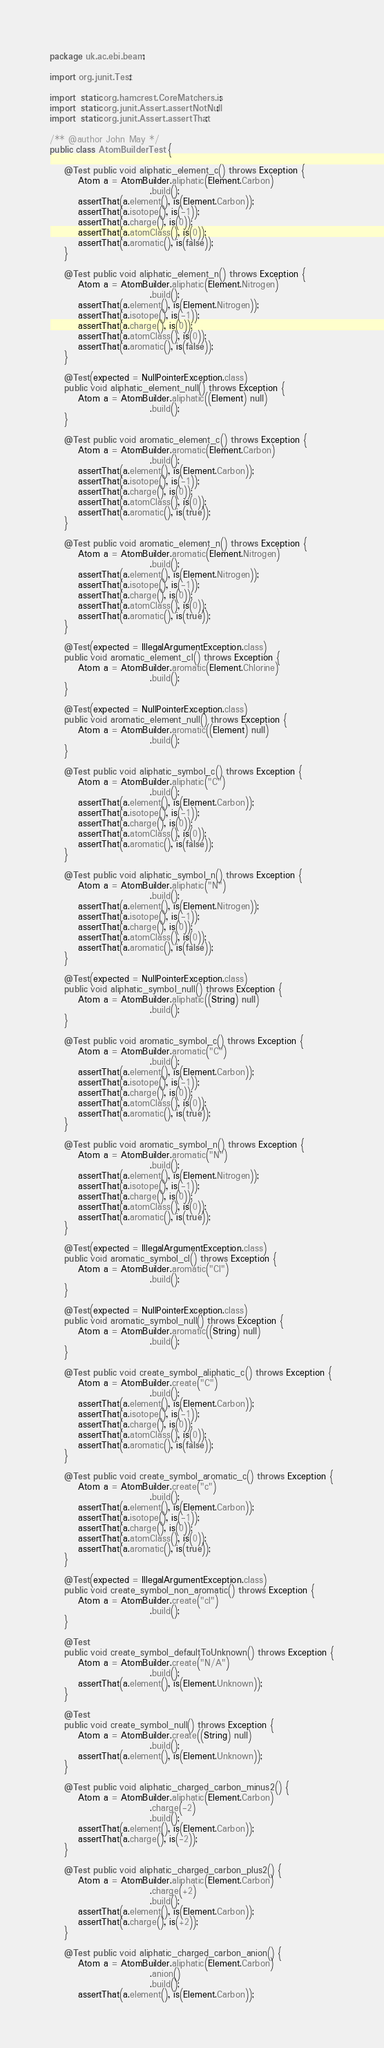Convert code to text. <code><loc_0><loc_0><loc_500><loc_500><_Java_>package uk.ac.ebi.beam;

import org.junit.Test;

import static org.hamcrest.CoreMatchers.is;
import static org.junit.Assert.assertNotNull;
import static org.junit.Assert.assertThat;

/** @author John May */
public class AtomBuilderTest {

    @Test public void aliphatic_element_c() throws Exception {
        Atom a = AtomBuilder.aliphatic(Element.Carbon)
                            .build();
        assertThat(a.element(), is(Element.Carbon));
        assertThat(a.isotope(), is(-1));
        assertThat(a.charge(), is(0));
        assertThat(a.atomClass(), is(0));
        assertThat(a.aromatic(), is(false));
    }

    @Test public void aliphatic_element_n() throws Exception {
        Atom a = AtomBuilder.aliphatic(Element.Nitrogen)
                            .build();
        assertThat(a.element(), is(Element.Nitrogen));
        assertThat(a.isotope(), is(-1));
        assertThat(a.charge(), is(0));
        assertThat(a.atomClass(), is(0));
        assertThat(a.aromatic(), is(false));
    }

    @Test(expected = NullPointerException.class)
    public void aliphatic_element_null() throws Exception {
        Atom a = AtomBuilder.aliphatic((Element) null)
                            .build();
    }

    @Test public void aromatic_element_c() throws Exception {
        Atom a = AtomBuilder.aromatic(Element.Carbon)
                            .build();
        assertThat(a.element(), is(Element.Carbon));
        assertThat(a.isotope(), is(-1));
        assertThat(a.charge(), is(0));
        assertThat(a.atomClass(), is(0));
        assertThat(a.aromatic(), is(true));
    }

    @Test public void aromatic_element_n() throws Exception {
        Atom a = AtomBuilder.aromatic(Element.Nitrogen)
                            .build();
        assertThat(a.element(), is(Element.Nitrogen));
        assertThat(a.isotope(), is(-1));
        assertThat(a.charge(), is(0));
        assertThat(a.atomClass(), is(0));
        assertThat(a.aromatic(), is(true));
    }

    @Test(expected = IllegalArgumentException.class)
    public void aromatic_element_cl() throws Exception {
        Atom a = AtomBuilder.aromatic(Element.Chlorine)
                            .build();
    }

    @Test(expected = NullPointerException.class)
    public void aromatic_element_null() throws Exception {
        Atom a = AtomBuilder.aromatic((Element) null)
                            .build();
    }

    @Test public void aliphatic_symbol_c() throws Exception {
        Atom a = AtomBuilder.aliphatic("C")
                            .build();
        assertThat(a.element(), is(Element.Carbon));
        assertThat(a.isotope(), is(-1));
        assertThat(a.charge(), is(0));
        assertThat(a.atomClass(), is(0));
        assertThat(a.aromatic(), is(false));
    }

    @Test public void aliphatic_symbol_n() throws Exception {
        Atom a = AtomBuilder.aliphatic("N")
                            .build();
        assertThat(a.element(), is(Element.Nitrogen));
        assertThat(a.isotope(), is(-1));
        assertThat(a.charge(), is(0));
        assertThat(a.atomClass(), is(0));
        assertThat(a.aromatic(), is(false));
    }

    @Test(expected = NullPointerException.class)
    public void aliphatic_symbol_null() throws Exception {
        Atom a = AtomBuilder.aliphatic((String) null)
                            .build();
    }

    @Test public void aromatic_symbol_c() throws Exception {
        Atom a = AtomBuilder.aromatic("C")
                            .build();
        assertThat(a.element(), is(Element.Carbon));
        assertThat(a.isotope(), is(-1));
        assertThat(a.charge(), is(0));
        assertThat(a.atomClass(), is(0));
        assertThat(a.aromatic(), is(true));
    }

    @Test public void aromatic_symbol_n() throws Exception {
        Atom a = AtomBuilder.aromatic("N")
                            .build();
        assertThat(a.element(), is(Element.Nitrogen));
        assertThat(a.isotope(), is(-1));
        assertThat(a.charge(), is(0));
        assertThat(a.atomClass(), is(0));
        assertThat(a.aromatic(), is(true));
    }

    @Test(expected = IllegalArgumentException.class)
    public void aromatic_symbol_cl() throws Exception {
        Atom a = AtomBuilder.aromatic("Cl")
                            .build();
    }

    @Test(expected = NullPointerException.class)
    public void aromatic_symbol_null() throws Exception {
        Atom a = AtomBuilder.aromatic((String) null)
                            .build();
    }

    @Test public void create_symbol_aliphatic_c() throws Exception {
        Atom a = AtomBuilder.create("C")
                            .build();
        assertThat(a.element(), is(Element.Carbon));
        assertThat(a.isotope(), is(-1));
        assertThat(a.charge(), is(0));
        assertThat(a.atomClass(), is(0));
        assertThat(a.aromatic(), is(false));
    }

    @Test public void create_symbol_aromatic_c() throws Exception {
        Atom a = AtomBuilder.create("c")
                            .build();
        assertThat(a.element(), is(Element.Carbon));
        assertThat(a.isotope(), is(-1));
        assertThat(a.charge(), is(0));
        assertThat(a.atomClass(), is(0));
        assertThat(a.aromatic(), is(true));
    }

    @Test(expected = IllegalArgumentException.class)
    public void create_symbol_non_aromatic() throws Exception {
        Atom a = AtomBuilder.create("cl")
                            .build();
    }

    @Test
    public void create_symbol_defaultToUnknown() throws Exception {
        Atom a = AtomBuilder.create("N/A")
                            .build();
        assertThat(a.element(), is(Element.Unknown));
    }

    @Test
    public void create_symbol_null() throws Exception {
        Atom a = AtomBuilder.create((String) null)
                            .build();
        assertThat(a.element(), is(Element.Unknown));
    }

    @Test public void aliphatic_charged_carbon_minus2() {
        Atom a = AtomBuilder.aliphatic(Element.Carbon)
                            .charge(-2)
                            .build();
        assertThat(a.element(), is(Element.Carbon));
        assertThat(a.charge(), is(-2));
    }

    @Test public void aliphatic_charged_carbon_plus2() {
        Atom a = AtomBuilder.aliphatic(Element.Carbon)
                            .charge(+2)
                            .build();
        assertThat(a.element(), is(Element.Carbon));
        assertThat(a.charge(), is(+2));
    }

    @Test public void aliphatic_charged_carbon_anion() {
        Atom a = AtomBuilder.aliphatic(Element.Carbon)
                            .anion()
                            .build();
        assertThat(a.element(), is(Element.Carbon));</code> 